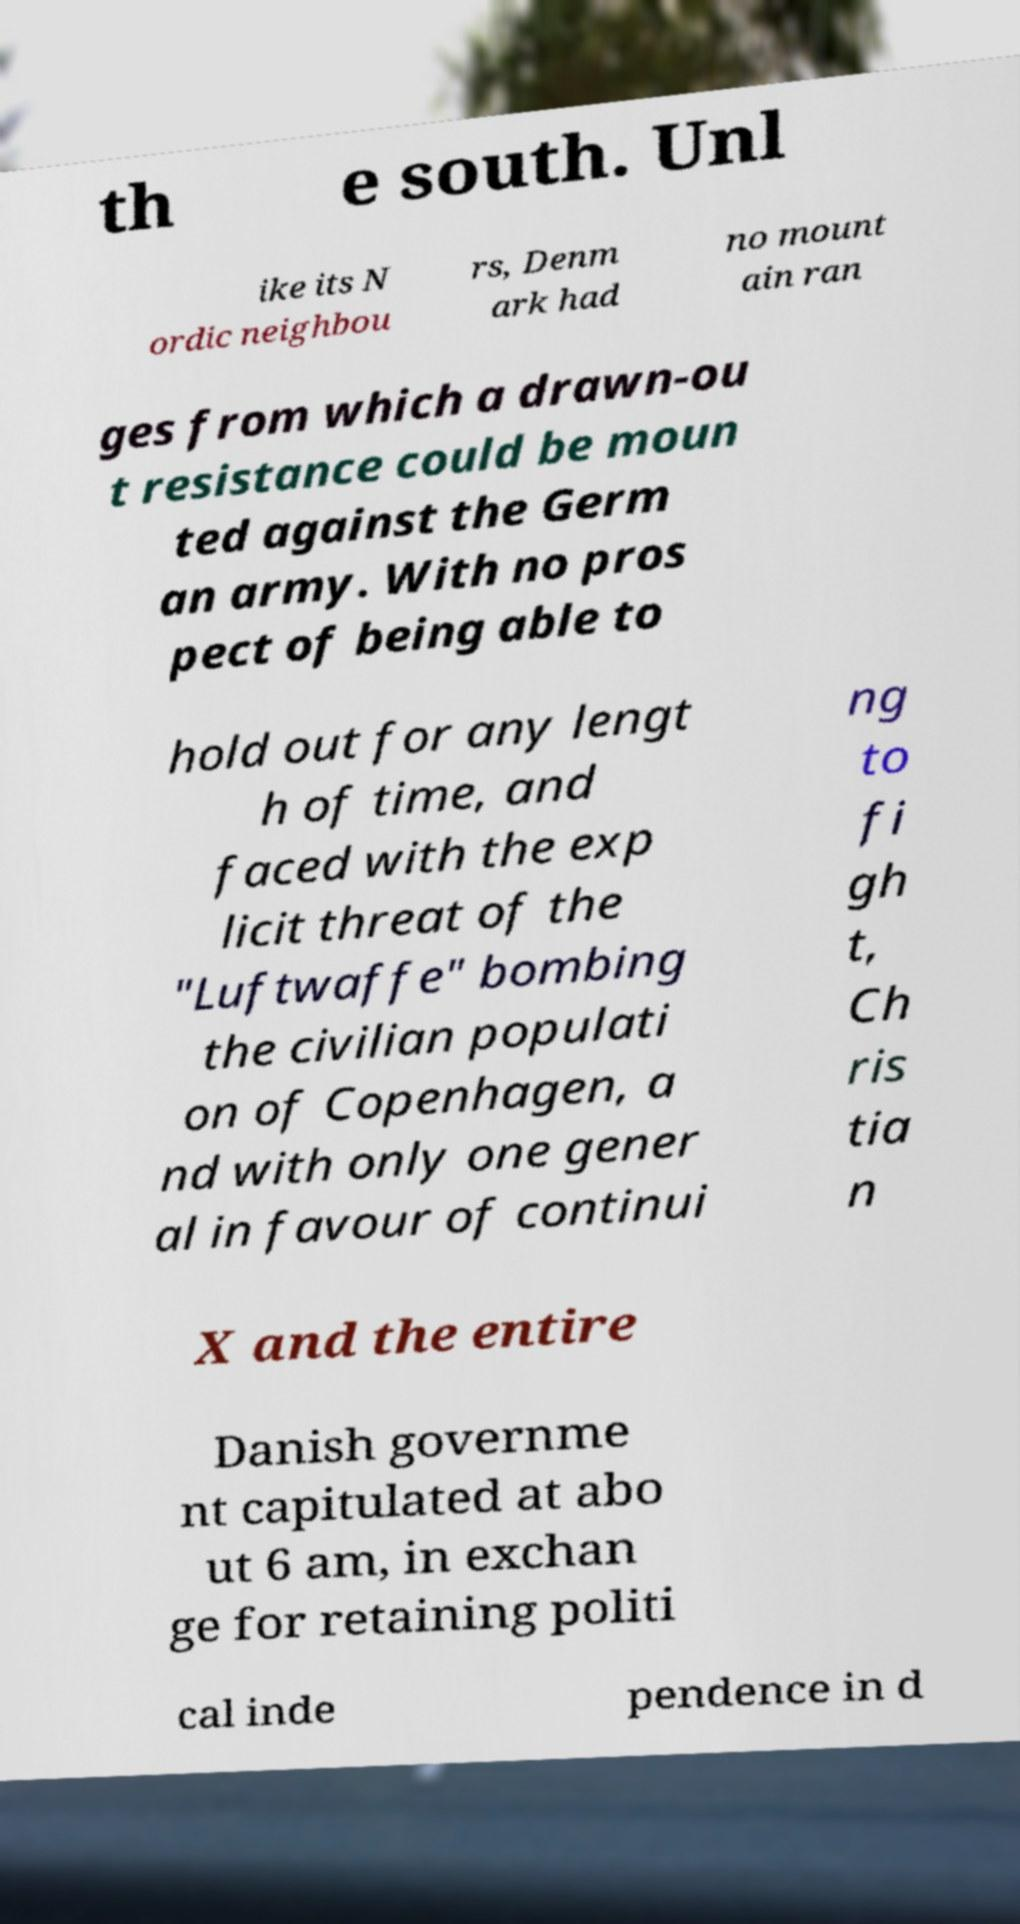Can you accurately transcribe the text from the provided image for me? th e south. Unl ike its N ordic neighbou rs, Denm ark had no mount ain ran ges from which a drawn-ou t resistance could be moun ted against the Germ an army. With no pros pect of being able to hold out for any lengt h of time, and faced with the exp licit threat of the "Luftwaffe" bombing the civilian populati on of Copenhagen, a nd with only one gener al in favour of continui ng to fi gh t, Ch ris tia n X and the entire Danish governme nt capitulated at abo ut 6 am, in exchan ge for retaining politi cal inde pendence in d 